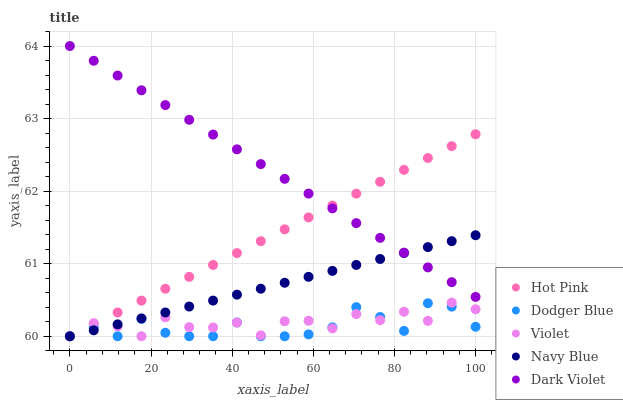Does Dodger Blue have the minimum area under the curve?
Answer yes or no. Yes. Does Dark Violet have the maximum area under the curve?
Answer yes or no. Yes. Does Hot Pink have the minimum area under the curve?
Answer yes or no. No. Does Hot Pink have the maximum area under the curve?
Answer yes or no. No. Is Dark Violet the smoothest?
Answer yes or no. Yes. Is Violet the roughest?
Answer yes or no. Yes. Is Hot Pink the smoothest?
Answer yes or no. No. Is Hot Pink the roughest?
Answer yes or no. No. Does Navy Blue have the lowest value?
Answer yes or no. Yes. Does Dark Violet have the lowest value?
Answer yes or no. No. Does Dark Violet have the highest value?
Answer yes or no. Yes. Does Hot Pink have the highest value?
Answer yes or no. No. Is Dodger Blue less than Dark Violet?
Answer yes or no. Yes. Is Dark Violet greater than Violet?
Answer yes or no. Yes. Does Dodger Blue intersect Navy Blue?
Answer yes or no. Yes. Is Dodger Blue less than Navy Blue?
Answer yes or no. No. Is Dodger Blue greater than Navy Blue?
Answer yes or no. No. Does Dodger Blue intersect Dark Violet?
Answer yes or no. No. 